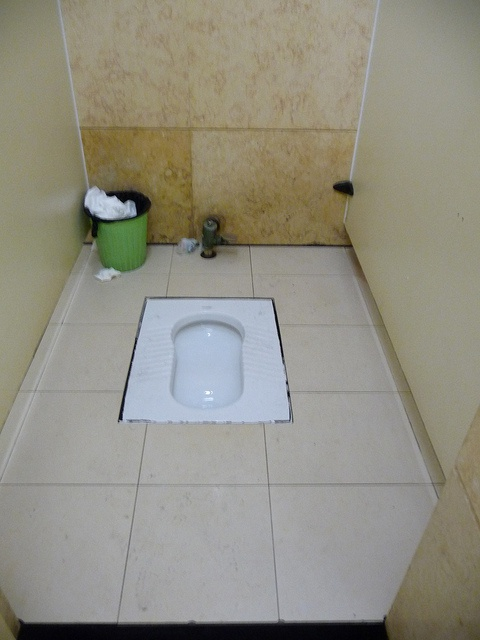Describe the objects in this image and their specific colors. I can see a toilet in gray, darkgray, and lightgray tones in this image. 